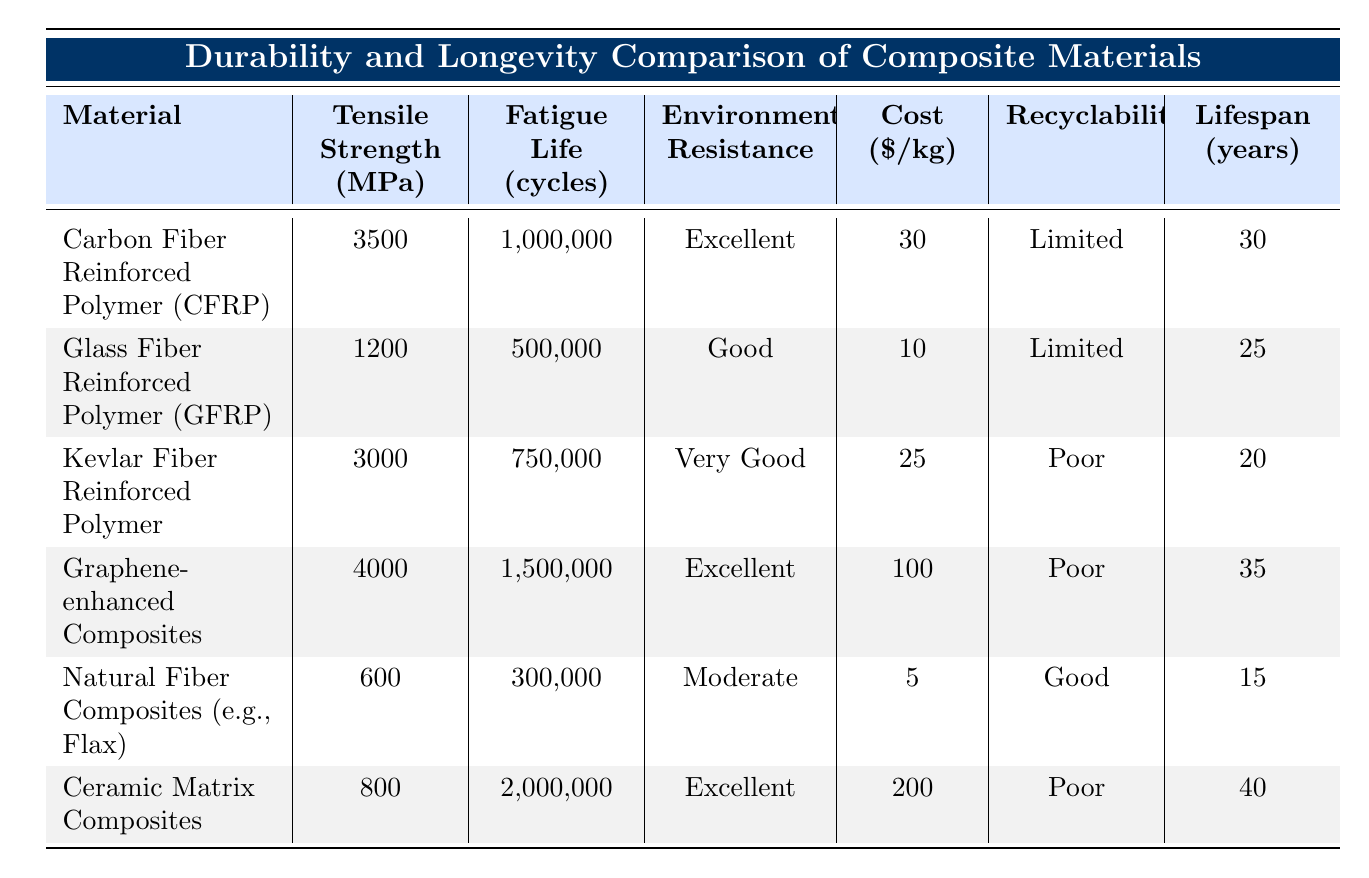What is the tensile strength of Carbon Fiber Reinforced Polymer? The table shows that the tensile strength of Carbon Fiber Reinforced Polymer (CFRP) is listed as 3500 MPa.
Answer: 3500 MPa Which material has the highest fatigue life in cycles? Upon checking the fatigue life values in the table, Ceramic Matrix Composites have the highest fatigue life, which is 2000000 cycles.
Answer: Ceramic Matrix Composites Is the environmental resistance of Kevlar Fiber Reinforced Polymer categorized as excellent? The table lists the environmental resistance of Kevlar Fiber Reinforced Polymer as "Very Good," not "Excellent." Thus, the statement is false.
Answer: No What is the difference in cost per kilogram between Graphene-enhanced Composites and Natural Fiber Composites? The cost of Graphene-enhanced Composites is 100 dollars per kilogram, while Natural Fiber Composites cost 5 dollars per kilogram. The difference is 100 - 5 = 95 dollars.
Answer: 95 dollars What is the average lifespan of Carbon Fiber Reinforced Polymer and Glass Fiber Reinforced Polymer combined? The lifespan of CFRP is 30 years and that of GFRP is 25 years. To find the average, we first add them: 30 + 25 = 55 years, then divide by 2 to get the average: 55 / 2 = 27.5 years.
Answer: 27.5 years Are all materials listed in the table recyclable? The table indicates varying recyclability across the materials, with some listed as "Limited" or "Poor." Therefore, not all materials are recyclable, making this statement false.
Answer: No Which material has the lowest tensile strength and what is its value? According to the data in the table, Natural Fiber Composites have the lowest tensile strength of 600 MPa.
Answer: 600 MPa If we consider the average cost of the four highlighted composite materials (CFRP, GFRP, Kevlar, and Graphene-enhanced Composites), what would it be? The costs are 30, 10, 25, and 100 dollars per kilogram respectively. First, we compute the total: 30 + 10 + 25 + 100 = 165 dollars. Then, we divide by 4 for the average: 165 / 4 = 41.25 dollars.
Answer: 41.25 dollars What is the environmental resistance of Glass Fiber Reinforced Polymer? The table shows that the environmental resistance of Glass Fiber Reinforced Polymer is categorized as "Good."
Answer: Good 